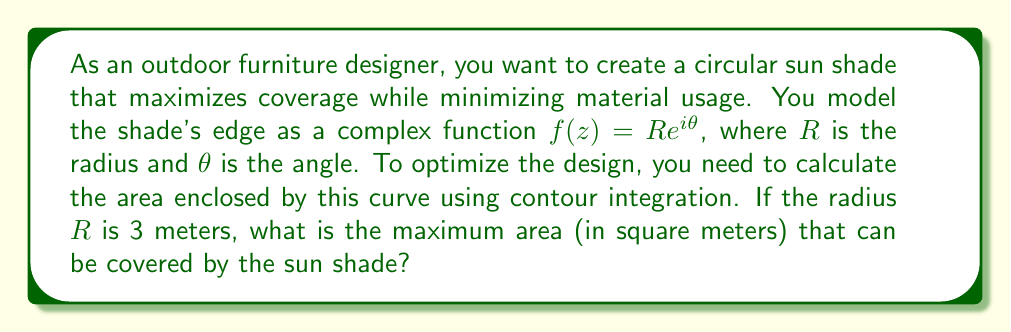Show me your answer to this math problem. To solve this problem, we'll use the following steps:

1) The area enclosed by a closed curve in the complex plane can be calculated using the formula:

   $$A = -\frac{1}{2i} \oint_C z\,dz$$

2) For our circular sun shade, we have $f(z) = Re^{i\theta}$, where $R = 3$ and $0 \leq \theta \leq 2\pi$.

3) We need to express $z$ and $dz$ in terms of $\theta$:
   
   $z = Re^{i\theta}$
   $dz = iRe^{i\theta}d\theta$

4) Substituting these into our area formula:

   $$A = -\frac{1}{2i} \int_0^{2\pi} (Re^{i\theta})(iRe^{i\theta}d\theta)$$

5) Simplifying:

   $$A = -\frac{1}{2i} \int_0^{2\pi} iR^2e^{2i\theta}d\theta = \frac{R^2}{2} \int_0^{2\pi} e^{2i\theta}d\theta$$

6) The integral of $e^{2i\theta}$ over a full circle is zero, so we're left with:

   $$A = \frac{R^2}{2} \cdot 2\pi = \pi R^2$$

7) Substituting $R = 3$:

   $$A = \pi \cdot 3^2 = 9\pi$$

Therefore, the maximum area that can be covered by the sun shade is $9\pi$ square meters.
Answer: $9\pi$ square meters (approximately 28.27 square meters) 